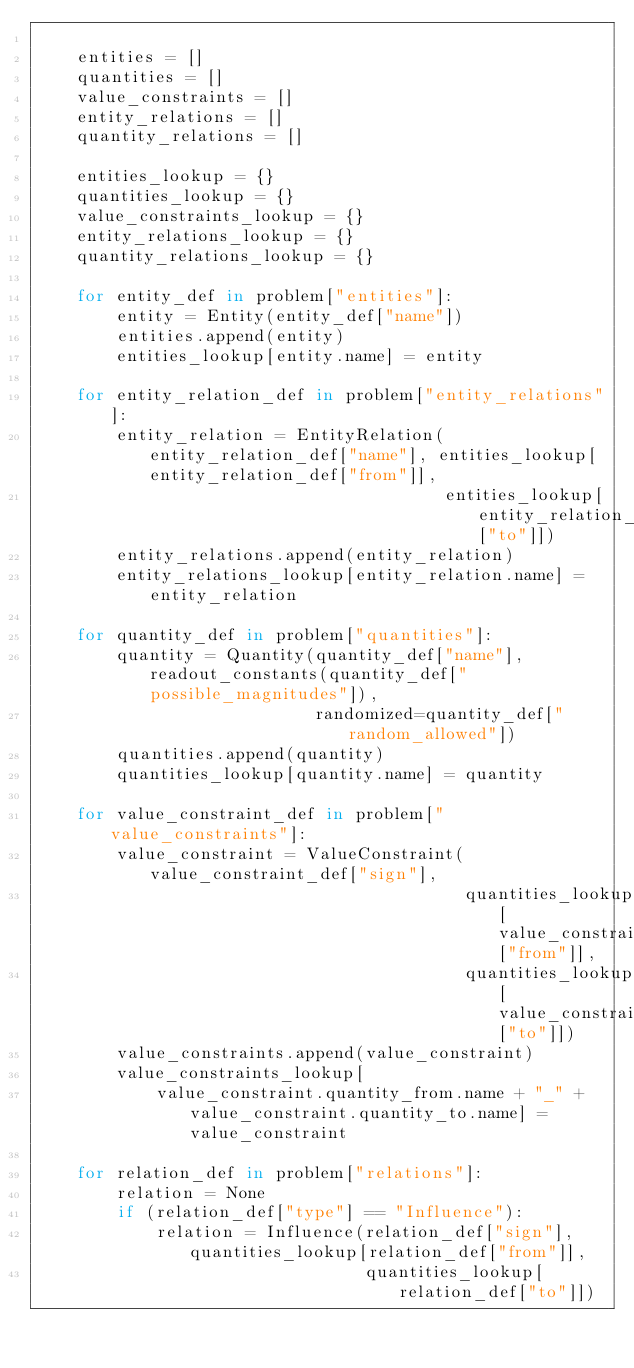<code> <loc_0><loc_0><loc_500><loc_500><_Python_>
    entities = []
    quantities = []
    value_constraints = []
    entity_relations = []
    quantity_relations = []

    entities_lookup = {}
    quantities_lookup = {}
    value_constraints_lookup = {}
    entity_relations_lookup = {}
    quantity_relations_lookup = {}

    for entity_def in problem["entities"]:
        entity = Entity(entity_def["name"])
        entities.append(entity)
        entities_lookup[entity.name] = entity

    for entity_relation_def in problem["entity_relations"]:
        entity_relation = EntityRelation(entity_relation_def["name"], entities_lookup[entity_relation_def["from"]],
                                         entities_lookup[entity_relation_def["to"]])
        entity_relations.append(entity_relation)
        entity_relations_lookup[entity_relation.name] = entity_relation

    for quantity_def in problem["quantities"]:
        quantity = Quantity(quantity_def["name"], readout_constants(quantity_def["possible_magnitudes"]),
                            randomized=quantity_def["random_allowed"])
        quantities.append(quantity)
        quantities_lookup[quantity.name] = quantity

    for value_constraint_def in problem["value_constraints"]:
        value_constraint = ValueConstraint(value_constraint_def["sign"],
                                           quantities_lookup[value_constraint_def["from"]],
                                           quantities_lookup[value_constraint_def["to"]])
        value_constraints.append(value_constraint)
        value_constraints_lookup[
            value_constraint.quantity_from.name + "_" + value_constraint.quantity_to.name] = value_constraint

    for relation_def in problem["relations"]:
        relation = None
        if (relation_def["type"] == "Influence"):
            relation = Influence(relation_def["sign"], quantities_lookup[relation_def["from"]],
                                 quantities_lookup[relation_def["to"]])</code> 